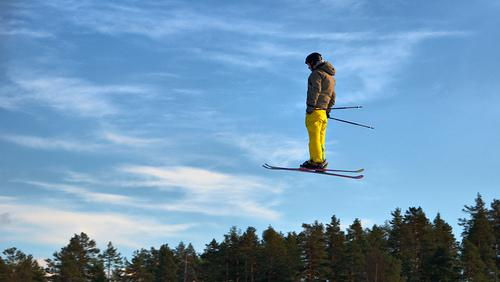Question: where is this scene?
Choices:
A. The airplane.
B. In the sky.
C. The pond.
D. The dance.
Answer with the letter. Answer: B Question: what sport is this?
Choices:
A. Sledding.
B. Tobogganing.
C. Skiing.
D. Cross country skiing.
Answer with the letter. Answer: C Question: what is in the sky?
Choices:
A. Clouds.
B. Planes.
C. Birds.
D. Kites.
Answer with the letter. Answer: A 